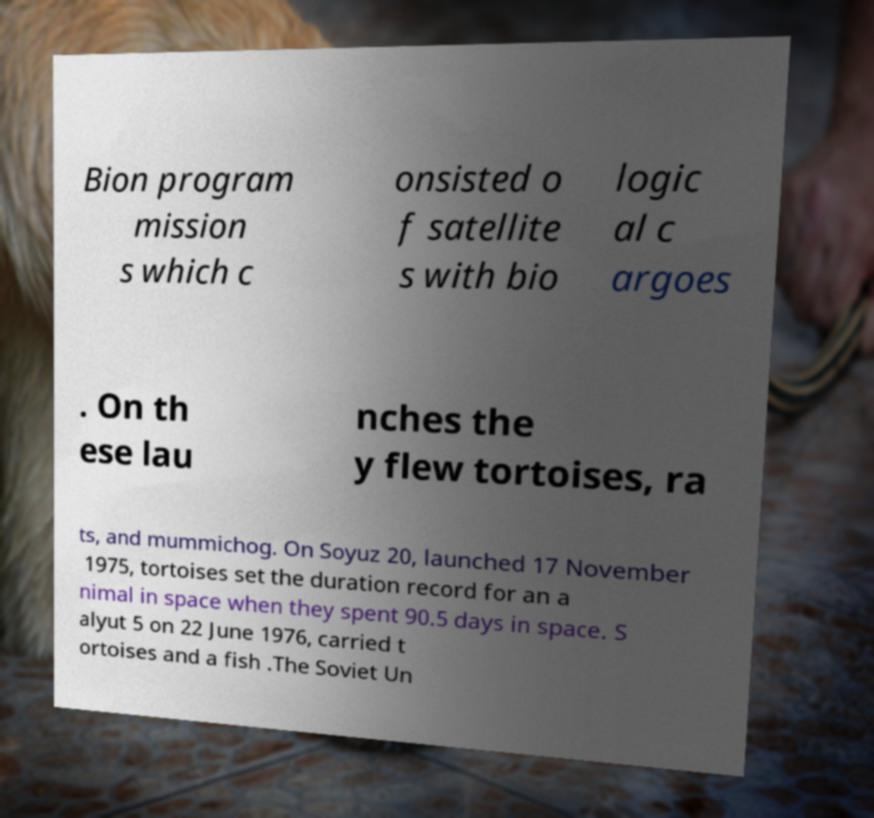Can you accurately transcribe the text from the provided image for me? Bion program mission s which c onsisted o f satellite s with bio logic al c argoes . On th ese lau nches the y flew tortoises, ra ts, and mummichog. On Soyuz 20, launched 17 November 1975, tortoises set the duration record for an a nimal in space when they spent 90.5 days in space. S alyut 5 on 22 June 1976, carried t ortoises and a fish .The Soviet Un 